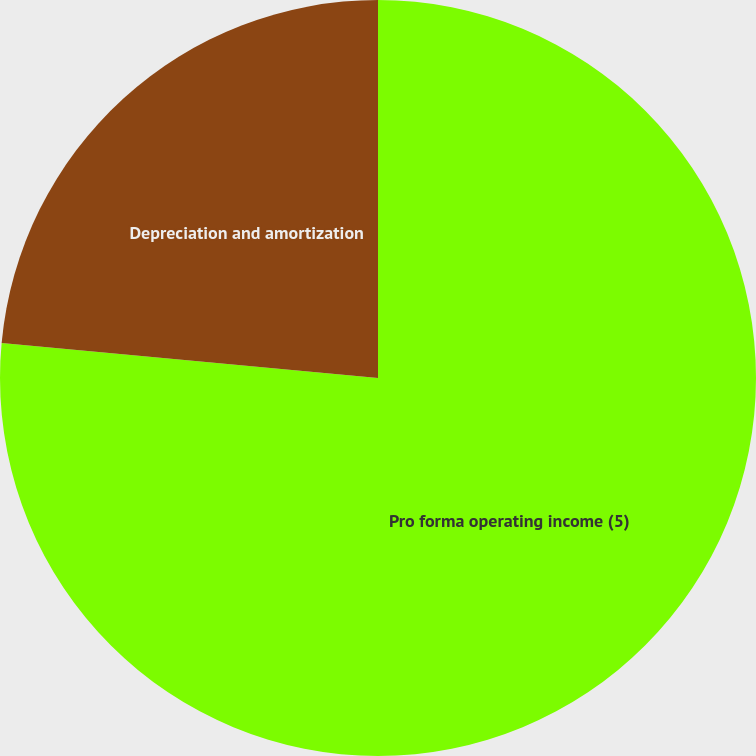Convert chart to OTSL. <chart><loc_0><loc_0><loc_500><loc_500><pie_chart><fcel>Pro forma operating income (5)<fcel>Depreciation and amortization<nl><fcel>76.48%<fcel>23.52%<nl></chart> 